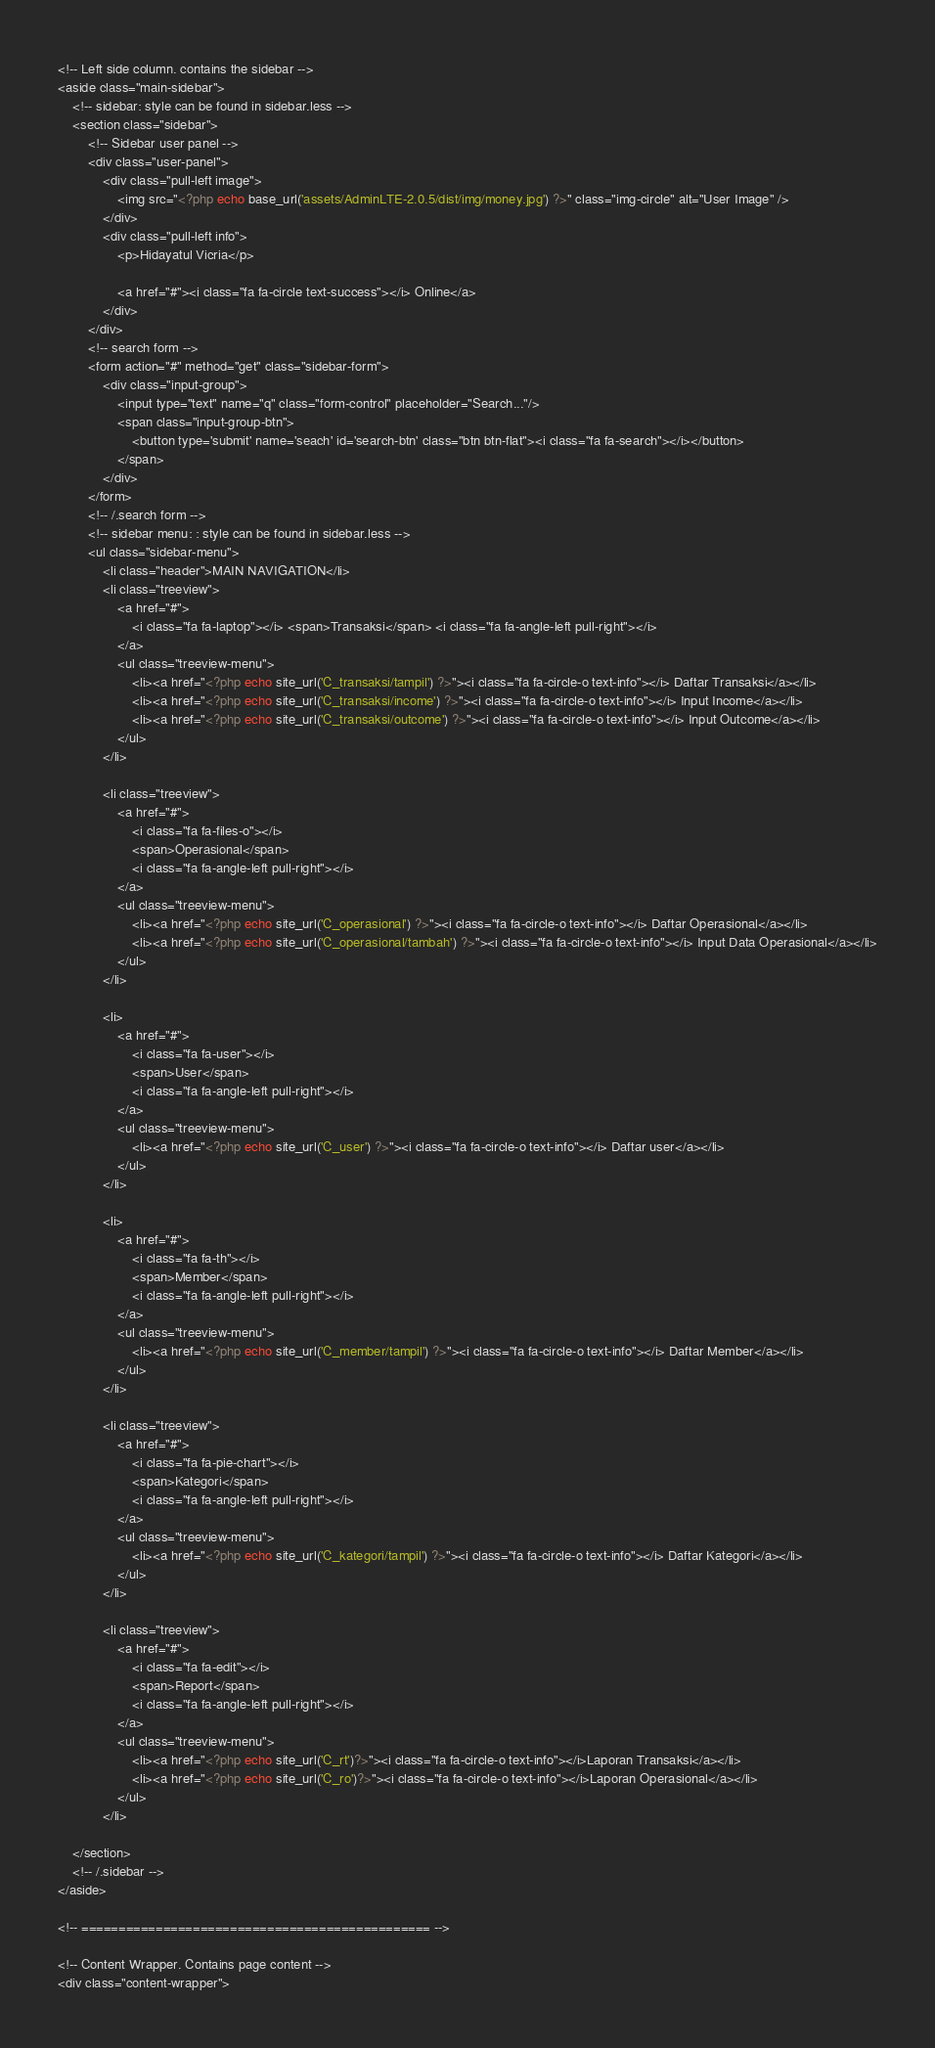Convert code to text. <code><loc_0><loc_0><loc_500><loc_500><_PHP_><!-- Left side column. contains the sidebar -->
<aside class="main-sidebar">
    <!-- sidebar: style can be found in sidebar.less -->
    <section class="sidebar">
        <!-- Sidebar user panel -->
        <div class="user-panel">
            <div class="pull-left image">
                <img src="<?php echo base_url('assets/AdminLTE-2.0.5/dist/img/money.jpg') ?>" class="img-circle" alt="User Image" />
            </div>
            <div class="pull-left info">
                <p>Hidayatul Vicria</p>

                <a href="#"><i class="fa fa-circle text-success"></i> Online</a>
            </div>
        </div>
        <!-- search form -->
        <form action="#" method="get" class="sidebar-form">
            <div class="input-group">
                <input type="text" name="q" class="form-control" placeholder="Search..."/>
                <span class="input-group-btn">
                    <button type='submit' name='seach' id='search-btn' class="btn btn-flat"><i class="fa fa-search"></i></button>
                </span>
            </div>
        </form>
        <!-- /.search form -->
        <!-- sidebar menu: : style can be found in sidebar.less -->
        <ul class="sidebar-menu">
            <li class="header">MAIN NAVIGATION</li>
            <li class="treeview">
                <a href="#">
                    <i class="fa fa-laptop"></i> <span>Transaksi</span> <i class="fa fa-angle-left pull-right"></i>
                </a>
                <ul class="treeview-menu">
                    <li><a href="<?php echo site_url('C_transaksi/tampil') ?>"><i class="fa fa-circle-o text-info"></i> Daftar Transaksi</a></li>
                    <li><a href="<?php echo site_url('C_transaksi/income') ?>"><i class="fa fa-circle-o text-info"></i> Input Income</a></li>
                    <li><a href="<?php echo site_url('C_transaksi/outcome') ?>"><i class="fa fa-circle-o text-info"></i> Input Outcome</a></li>
                </ul>
            </li>

            <li class="treeview">
                <a href="#">
                    <i class="fa fa-files-o"></i>
                    <span>Operasional</span>
                    <i class="fa fa-angle-left pull-right"></i>
                </a>
                <ul class="treeview-menu">
                    <li><a href="<?php echo site_url('C_operasional') ?>"><i class="fa fa-circle-o text-info"></i> Daftar Operasional</a></li>
                    <li><a href="<?php echo site_url('C_operasional/tambah') ?>"><i class="fa fa-circle-o text-info"></i> Input Data Operasional</a></li>
                </ul>
            </li>

            <li>
                <a href="#">
                    <i class="fa fa-user"></i> 
                    <span>User</span>
                    <i class="fa fa-angle-left pull-right"></i>
                </a>
                <ul class="treeview-menu">
                    <li><a href="<?php echo site_url('C_user') ?>"><i class="fa fa-circle-o text-info"></i> Daftar user</a></li>
                </ul>
            </li>

            <li>
                <a href="#">
                    <i class="fa fa-th"></i> 
                    <span>Member</span>
                    <i class="fa fa-angle-left pull-right"></i>
                </a>
                <ul class="treeview-menu">
                    <li><a href="<?php echo site_url('C_member/tampil') ?>"><i class="fa fa-circle-o text-info"></i> Daftar Member</a></li>
                </ul>
            </li>

            <li class="treeview">
                <a href="#">
                    <i class="fa fa-pie-chart"></i>
                    <span>Kategori</span>
                    <i class="fa fa-angle-left pull-right"></i>
                </a>
                <ul class="treeview-menu">
                    <li><a href="<?php echo site_url('C_kategori/tampil') ?>"><i class="fa fa-circle-o text-info"></i> Daftar Kategori</a></li>
                </ul>
            </li>

            <li class="treeview">
                <a href="#">
                    <i class="fa fa-edit"></i>
                    <span>Report</span>
                    <i class="fa fa-angle-left pull-right"></i>
                </a>
                <ul class="treeview-menu">
                    <li><a href="<?php echo site_url('C_rt')?>"><i class="fa fa-circle-o text-info"></i>Laporan Transaksi</a></li>
                    <li><a href="<?php echo site_url('C_ro')?>"><i class="fa fa-circle-o text-info"></i>Laporan Operasional</a></li>
                </ul>
            </li>

    </section>
    <!-- /.sidebar -->
</aside>

<!-- =============================================== -->

<!-- Content Wrapper. Contains page content -->
<div class="content-wrapper"></code> 